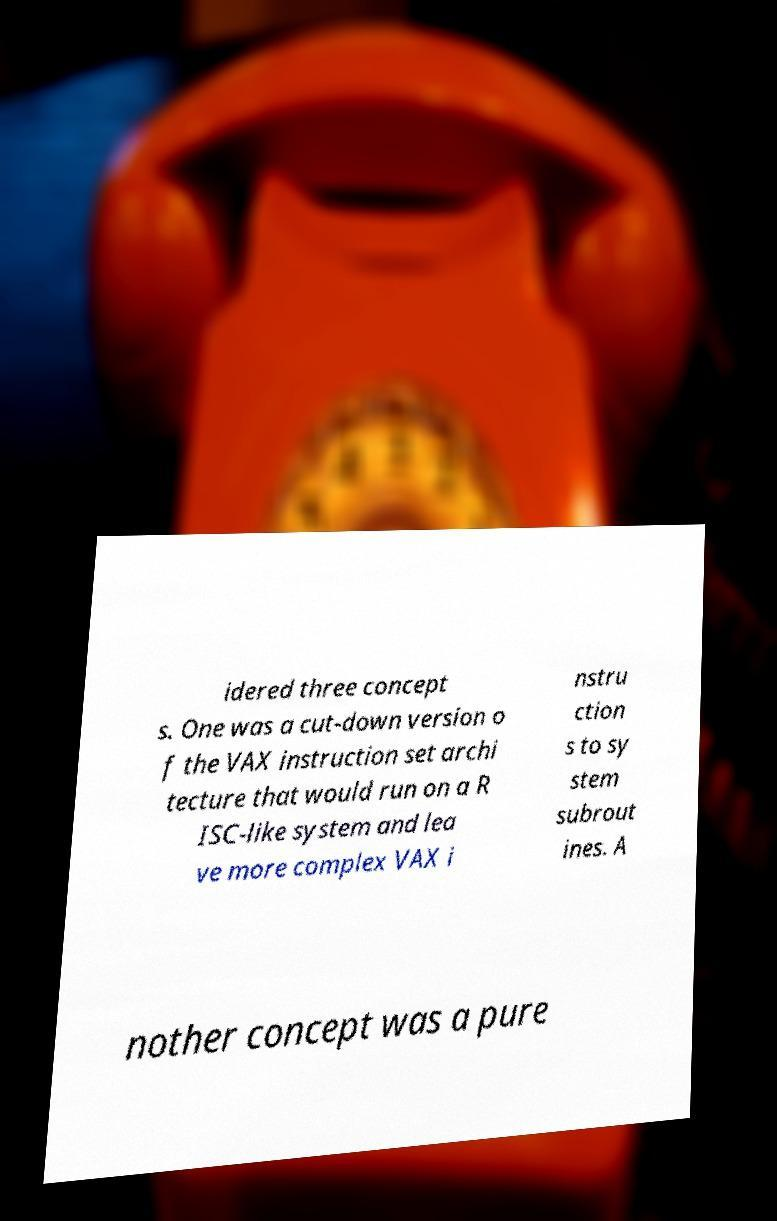There's text embedded in this image that I need extracted. Can you transcribe it verbatim? idered three concept s. One was a cut-down version o f the VAX instruction set archi tecture that would run on a R ISC-like system and lea ve more complex VAX i nstru ction s to sy stem subrout ines. A nother concept was a pure 